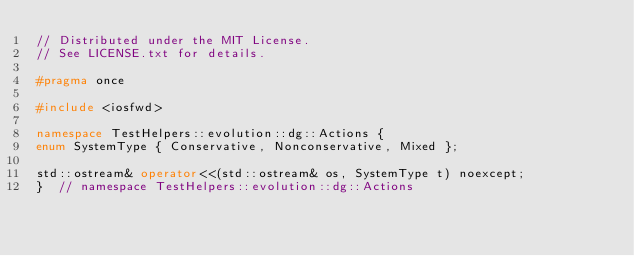<code> <loc_0><loc_0><loc_500><loc_500><_C++_>// Distributed under the MIT License.
// See LICENSE.txt for details.

#pragma once

#include <iosfwd>

namespace TestHelpers::evolution::dg::Actions {
enum SystemType { Conservative, Nonconservative, Mixed };

std::ostream& operator<<(std::ostream& os, SystemType t) noexcept;
}  // namespace TestHelpers::evolution::dg::Actions
</code> 